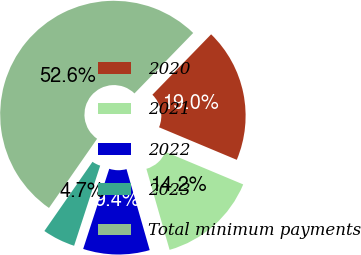Convert chart to OTSL. <chart><loc_0><loc_0><loc_500><loc_500><pie_chart><fcel>2020<fcel>2021<fcel>2022<fcel>2023<fcel>Total minimum payments<nl><fcel>19.04%<fcel>14.25%<fcel>9.45%<fcel>4.66%<fcel>52.6%<nl></chart> 